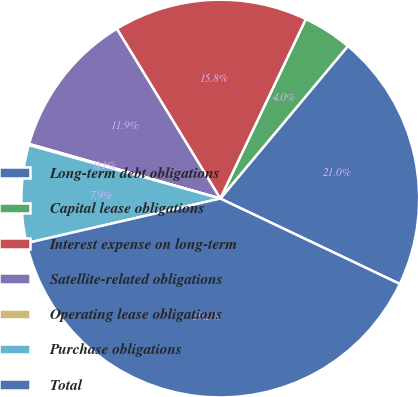Convert chart to OTSL. <chart><loc_0><loc_0><loc_500><loc_500><pie_chart><fcel>Long-term debt obligations<fcel>Capital lease obligations<fcel>Interest expense on long-term<fcel>Satellite-related obligations<fcel>Operating lease obligations<fcel>Purchase obligations<fcel>Total<nl><fcel>20.98%<fcel>4.01%<fcel>15.79%<fcel>11.86%<fcel>0.09%<fcel>7.94%<fcel>39.34%<nl></chart> 